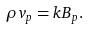Convert formula to latex. <formula><loc_0><loc_0><loc_500><loc_500>\rho { v _ { p } } = k { B _ { p } } .</formula> 